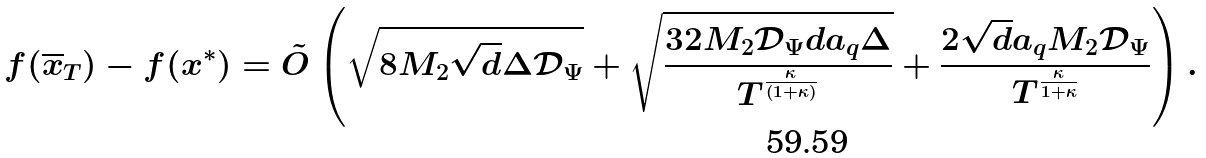<formula> <loc_0><loc_0><loc_500><loc_500>f ( \overline { x } _ { T } ) - f ( x ^ { * } ) = \tilde { O } \left ( \sqrt { 8 M _ { 2 } \sqrt { d } \Delta \mathcal { D } _ { \Psi } } + \sqrt { \frac { 3 2 M _ { 2 } \mathcal { D } _ { \Psi } d a _ { q } \Delta } { T ^ { \frac { \kappa } { ( 1 + \kappa ) } } } } + \frac { 2 \sqrt { d } a _ { q } M _ { 2 } \mathcal { D } _ { \Psi } } { T ^ { \frac { \kappa } { 1 + \kappa } } } \right ) .</formula> 